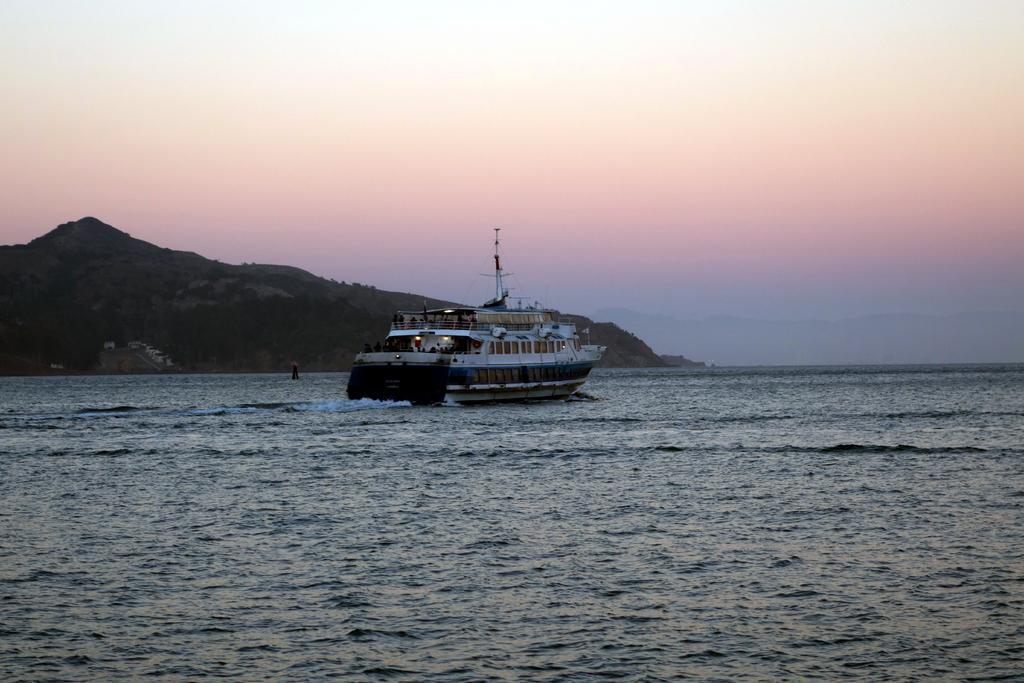Describe this image in one or two sentences. In the foreground of the picture there is a water body. In the center of the picture there is a ship. In the background there are trees and hills. 